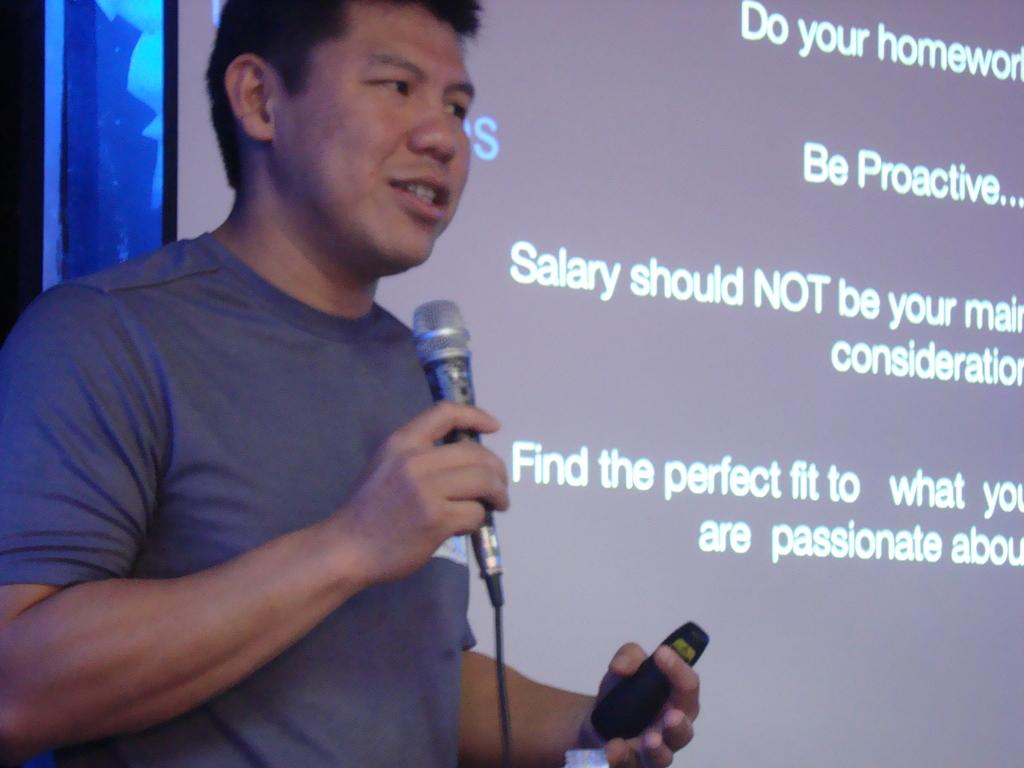What is the main subject of the image? There is a guy in the image. What is the guy holding in his right hand? The guy is holding a microphone in his right hand. What is the guy holding in his left hand? The guy is holding a remote in his left hand. What can be seen on the projector screen in the image? The facts provided do not mention what is on the projector screen, so we cannot answer that question definitively. What type of boat can be seen sailing in the background of the image? There is no boat present in the image; it features a guy holding a microphone and a remote, with a projector screen in the background. 